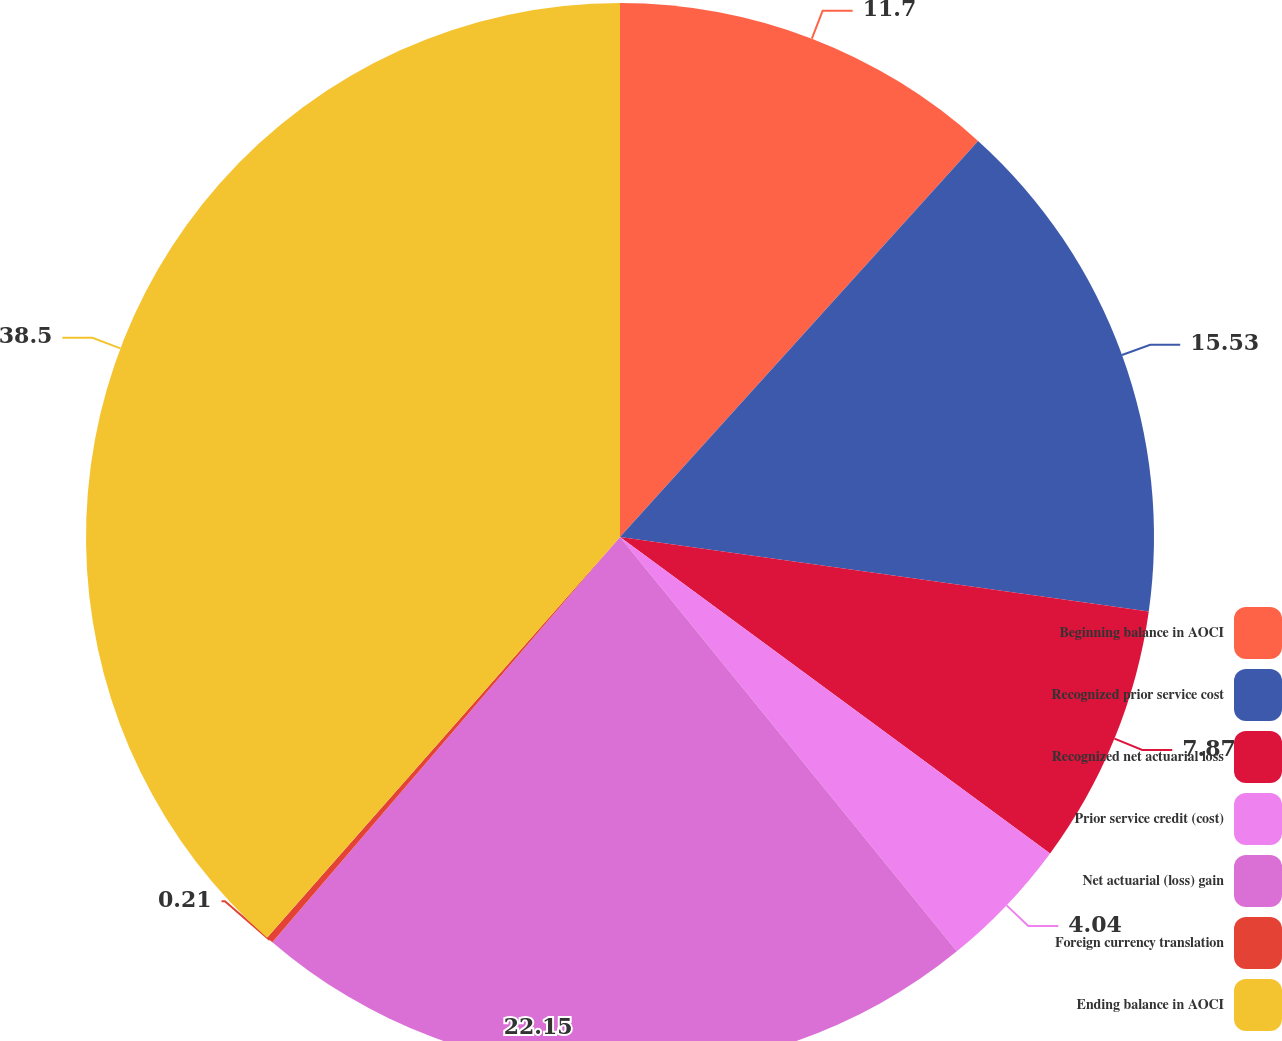Convert chart to OTSL. <chart><loc_0><loc_0><loc_500><loc_500><pie_chart><fcel>Beginning balance in AOCI<fcel>Recognized prior service cost<fcel>Recognized net actuarial loss<fcel>Prior service credit (cost)<fcel>Net actuarial (loss) gain<fcel>Foreign currency translation<fcel>Ending balance in AOCI<nl><fcel>11.7%<fcel>15.53%<fcel>7.87%<fcel>4.04%<fcel>22.15%<fcel>0.21%<fcel>38.51%<nl></chart> 